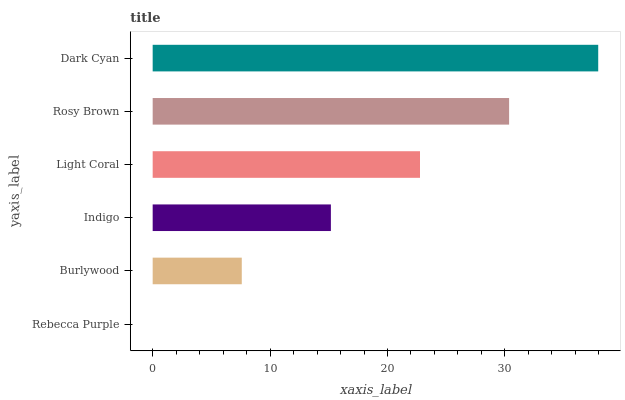Is Rebecca Purple the minimum?
Answer yes or no. Yes. Is Dark Cyan the maximum?
Answer yes or no. Yes. Is Burlywood the minimum?
Answer yes or no. No. Is Burlywood the maximum?
Answer yes or no. No. Is Burlywood greater than Rebecca Purple?
Answer yes or no. Yes. Is Rebecca Purple less than Burlywood?
Answer yes or no. Yes. Is Rebecca Purple greater than Burlywood?
Answer yes or no. No. Is Burlywood less than Rebecca Purple?
Answer yes or no. No. Is Light Coral the high median?
Answer yes or no. Yes. Is Indigo the low median?
Answer yes or no. Yes. Is Rosy Brown the high median?
Answer yes or no. No. Is Light Coral the low median?
Answer yes or no. No. 